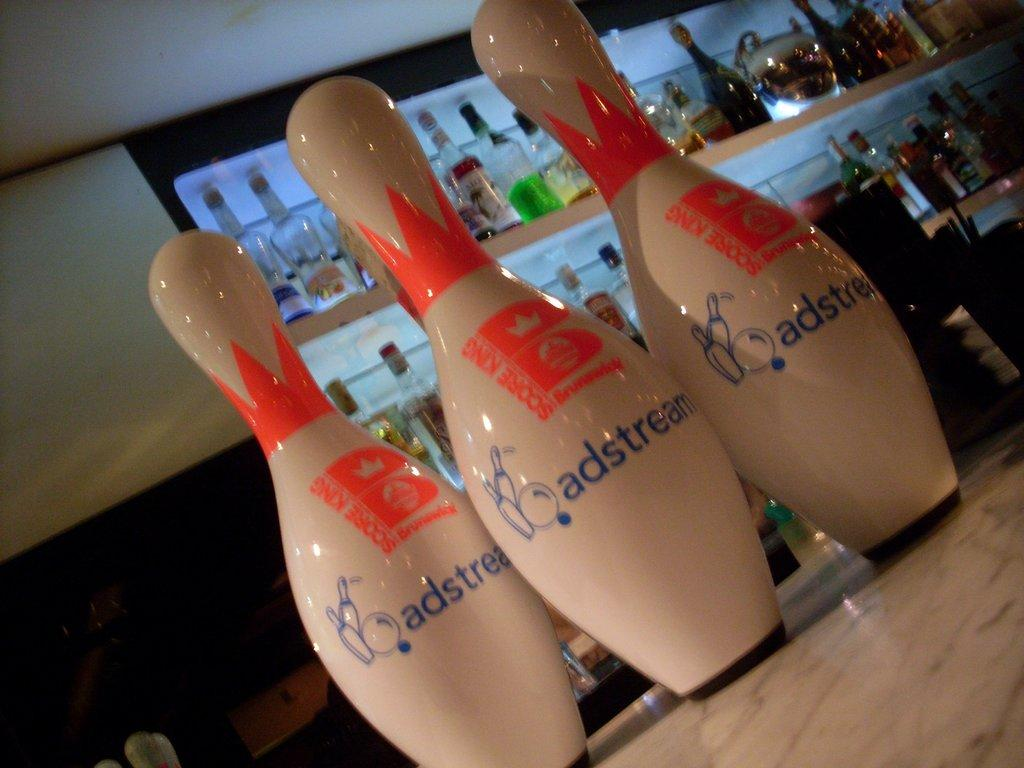Provide a one-sentence caption for the provided image. White bowling pins have blue lettering stating, adstream.". 